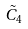Convert formula to latex. <formula><loc_0><loc_0><loc_500><loc_500>\tilde { C } _ { 4 }</formula> 